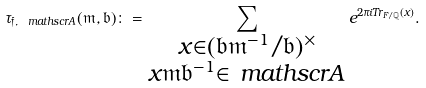Convert formula to latex. <formula><loc_0><loc_0><loc_500><loc_500>\tau _ { \mathfrak f , \ m a t h s c r A } ( \mathfrak m , \mathfrak b ) \colon = \sum _ { \substack { x \in ( \mathfrak b \mathfrak m ^ { - 1 } / \mathfrak b ) ^ { \times } \\ x \mathfrak m \mathfrak b ^ { - 1 } \in \ m a t h s c r A } } e ^ { 2 \pi i T r _ { F / \mathbb { Q } } ( x ) } .</formula> 